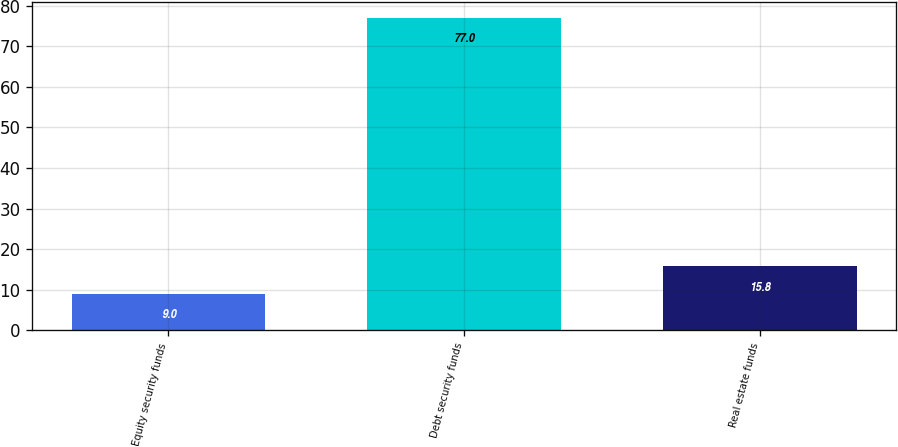<chart> <loc_0><loc_0><loc_500><loc_500><bar_chart><fcel>Equity security funds<fcel>Debt security funds<fcel>Real estate funds<nl><fcel>9<fcel>77<fcel>15.8<nl></chart> 